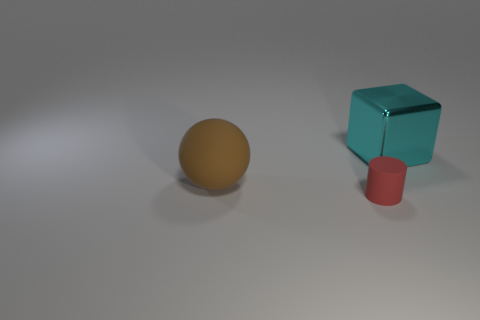What time of day does the lighting in the image suggest? The image features a soft shadow indicating diffuse light, which could suggest an overcast day. However, without a clear indication of a natural light source, the lighting could also be artificial, resembling studio lighting conditions. 